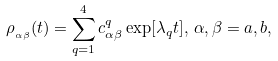<formula> <loc_0><loc_0><loc_500><loc_500>\rho _ { _ { \alpha \beta } } ( t ) = \sum _ { q = 1 } ^ { 4 } c _ { \alpha \beta } ^ { q } \exp [ \lambda _ { q } t ] , \, \alpha , \beta = a , b ,</formula> 